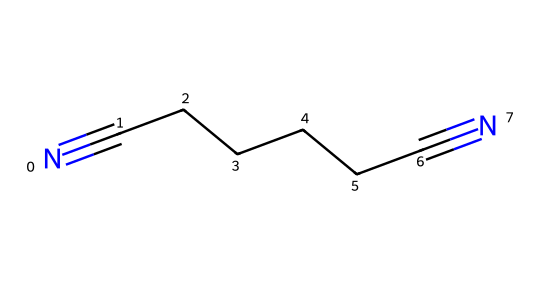What is the name of this chemical? The SMILES representation N#CCCCCC#N indicates a straight-chain nitrile with two cyanide (-C≡N) functional groups at each end, which is known as adiponitrile.
Answer: adiponitrile How many carbon atoms are in adiponitrile? The structure has a total of six carbon atoms represented by the six 'C' in the chain connecting the two cyanide groups which are not counted as carbon atoms.
Answer: 6 What type of functional groups are present in adiponitrile? The SMILES shows two terminal groups with the triple bond 'N#', indicating that adiponitrile possesses two nitrile functional groups, which are characterized by the carbon-nitrogen triple bond.
Answer: nitrile What is the total number of atoms in this molecule? Counting all atoms from the SMILES: 6 carbons, 10 hydrogens, and 2 nitrogens gives a total of 18 atoms.
Answer: 18 Does adiponitrile have any double or single bonds? The SMILES does not depict any double bonds but features triple bonds between carbon and nitrogen atoms (N#), indicating that adiponitrile only contains these types of bonds and no single or double bonds in its carbon chain.
Answer: no What is the primary industrial use of adiponitrile? Adiponitrile is primarily used as a precursor in the synthesis of nylon, particularly nylon 66, which is commonly used in outdoor furniture and various textiles.
Answer: nylon production What might be a property of adiponitrile related to its structure? The linear arrangement with cyanide groups suggests it may exhibit properties such as solubility in polar solvents and potential toxicity due to the presence of nitrile groups, behavior typical for nitriles.
Answer: solubility in polar solvents 